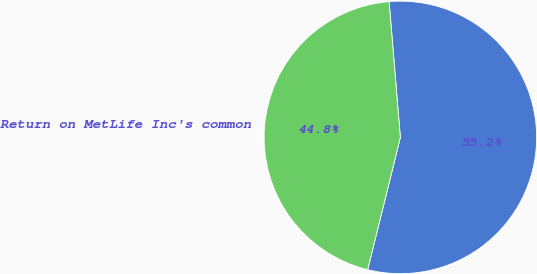<chart> <loc_0><loc_0><loc_500><loc_500><pie_chart><ecel><fcel>Return on MetLife Inc's common<nl><fcel>55.17%<fcel>44.83%<nl></chart> 